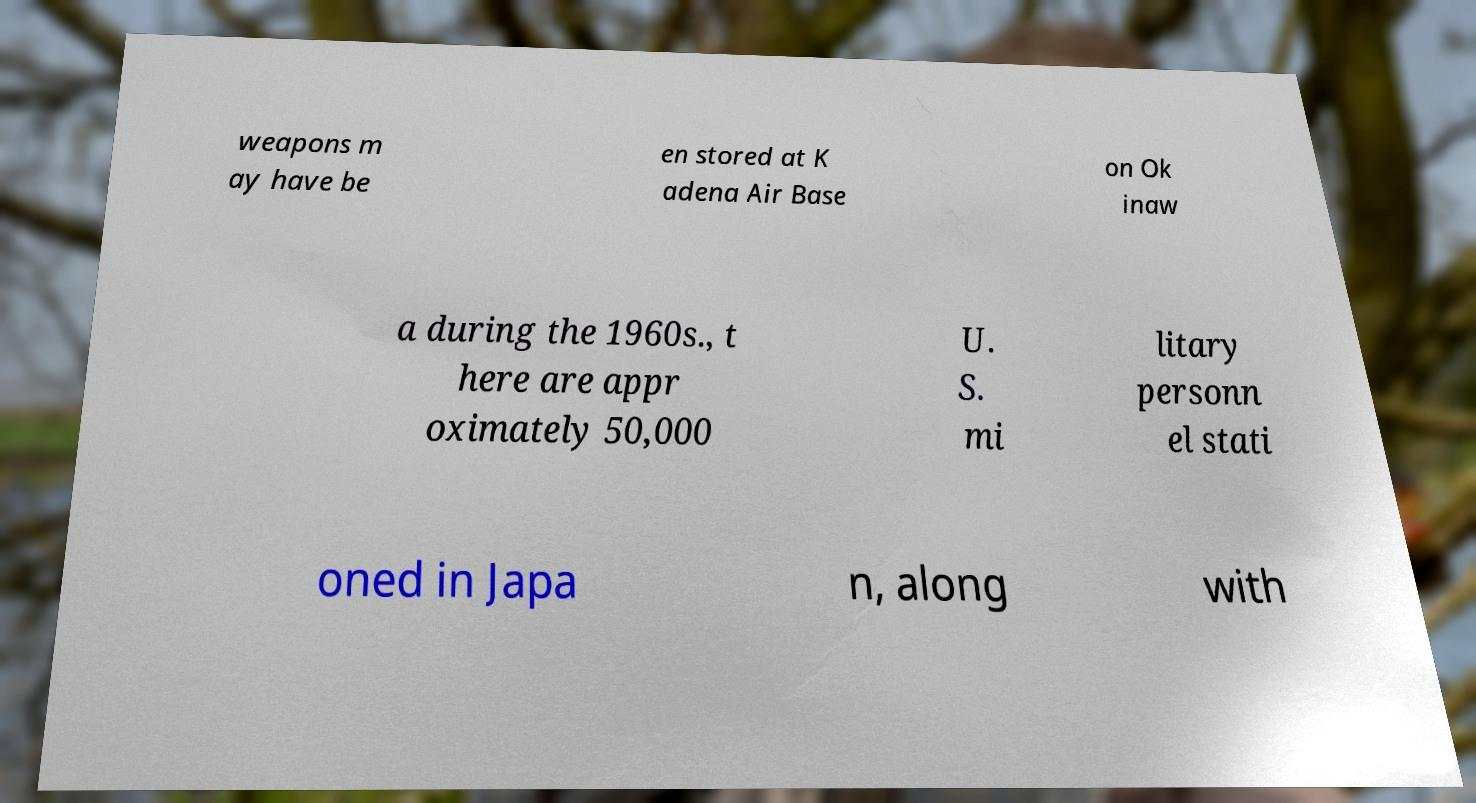For documentation purposes, I need the text within this image transcribed. Could you provide that? weapons m ay have be en stored at K adena Air Base on Ok inaw a during the 1960s., t here are appr oximately 50,000 U. S. mi litary personn el stati oned in Japa n, along with 